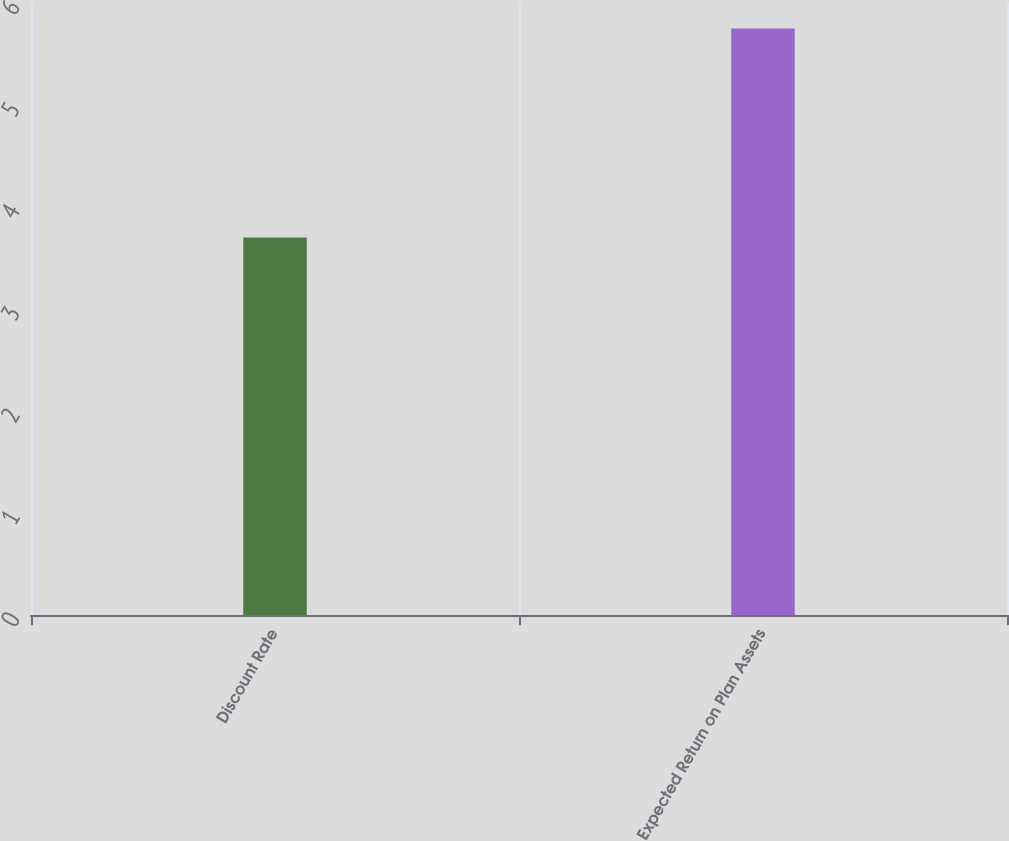Convert chart to OTSL. <chart><loc_0><loc_0><loc_500><loc_500><bar_chart><fcel>Discount Rate<fcel>Expected Return on Plan Assets<nl><fcel>3.7<fcel>5.75<nl></chart> 